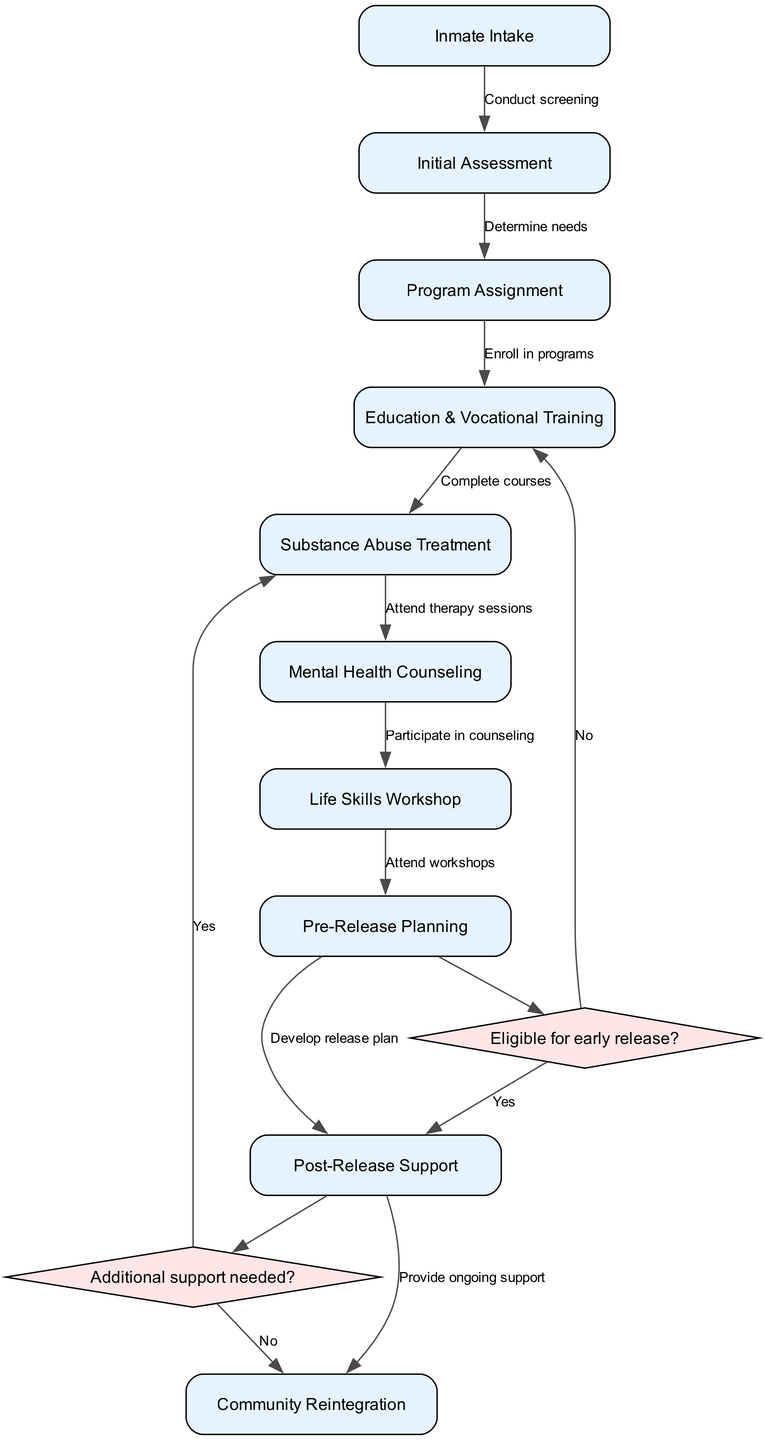What is the first node in the workflow? The first node is "Inmate Intake," as indicated in the diagram, where the process begins with the intake of an inmate.
Answer: Inmate Intake How many decision points are there? There are two decision points in the diagram, labeled as "Eligible for early release?" and "Additional support needed?".
Answer: 2 What happens if the decision point "Eligible for early release?" is answered with "No"? If "No" is selected, the process continues to "Education & Vocational Training," indicating that the inmate will not be considered for early release but will still engage in educational programs.
Answer: Education & Vocational Training What follows "Pre-Release Planning" if the decision point is answered "Yes"? If the answer to "Eligible for early release?" is "Yes," the next step is "Post-Release Support," showing that the inmate will receive assistance after release.
Answer: Post-Release Support What is the last node in the workflow? The last node is "Community Reintegration," which is the final step that concludes the rehabilitation program by focusing on reintegrating the inmate into society.
Answer: Community Reintegration 